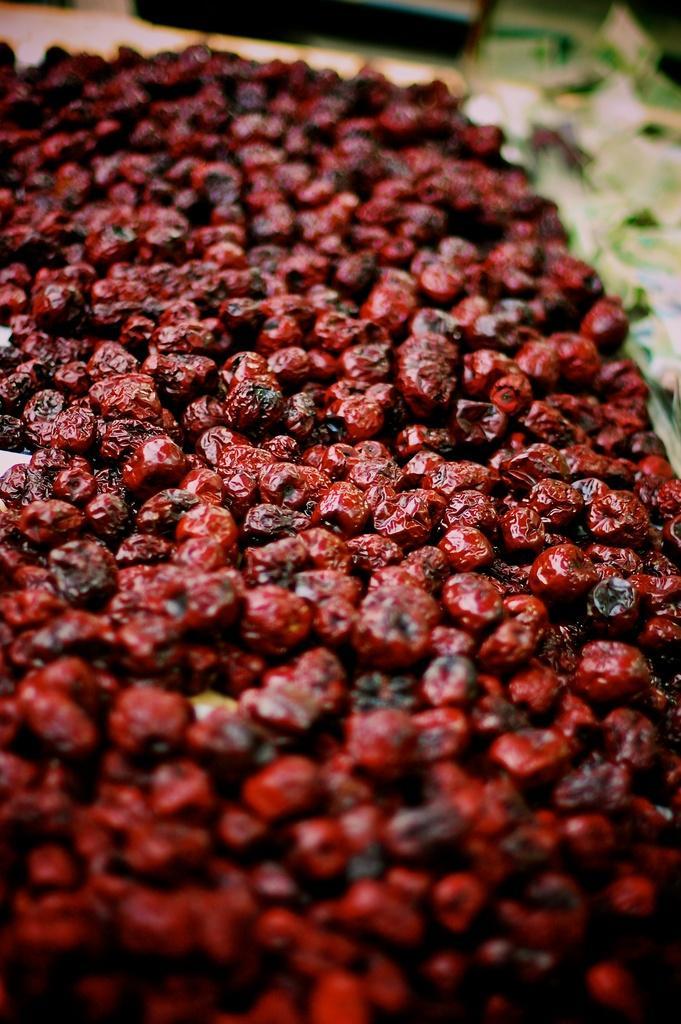In one or two sentences, can you explain what this image depicts? In this image we can see many fruits. There are few objects at the top of the image. 